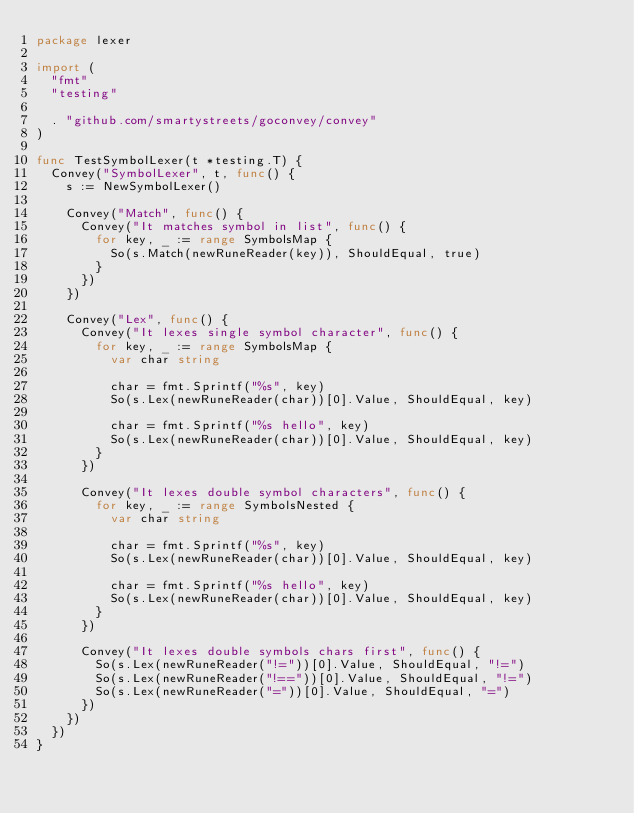<code> <loc_0><loc_0><loc_500><loc_500><_Go_>package lexer

import (
	"fmt"
	"testing"

	. "github.com/smartystreets/goconvey/convey"
)

func TestSymbolLexer(t *testing.T) {
	Convey("SymbolLexer", t, func() {
		s := NewSymbolLexer()

		Convey("Match", func() {
			Convey("It matches symbol in list", func() {
				for key, _ := range SymbolsMap {
					So(s.Match(newRuneReader(key)), ShouldEqual, true)
				}
			})
		})

		Convey("Lex", func() {
			Convey("It lexes single symbol character", func() {
				for key, _ := range SymbolsMap {
					var char string

					char = fmt.Sprintf("%s", key)
					So(s.Lex(newRuneReader(char))[0].Value, ShouldEqual, key)

					char = fmt.Sprintf("%s hello", key)
					So(s.Lex(newRuneReader(char))[0].Value, ShouldEqual, key)
				}
			})

			Convey("It lexes double symbol characters", func() {
				for key, _ := range SymbolsNested {
					var char string

					char = fmt.Sprintf("%s", key)
					So(s.Lex(newRuneReader(char))[0].Value, ShouldEqual, key)

					char = fmt.Sprintf("%s hello", key)
					So(s.Lex(newRuneReader(char))[0].Value, ShouldEqual, key)
				}
			})

			Convey("It lexes double symbols chars first", func() {
				So(s.Lex(newRuneReader("!="))[0].Value, ShouldEqual, "!=")
				So(s.Lex(newRuneReader("!=="))[0].Value, ShouldEqual, "!=")
				So(s.Lex(newRuneReader("="))[0].Value, ShouldEqual, "=")
			})
		})
	})
}
</code> 